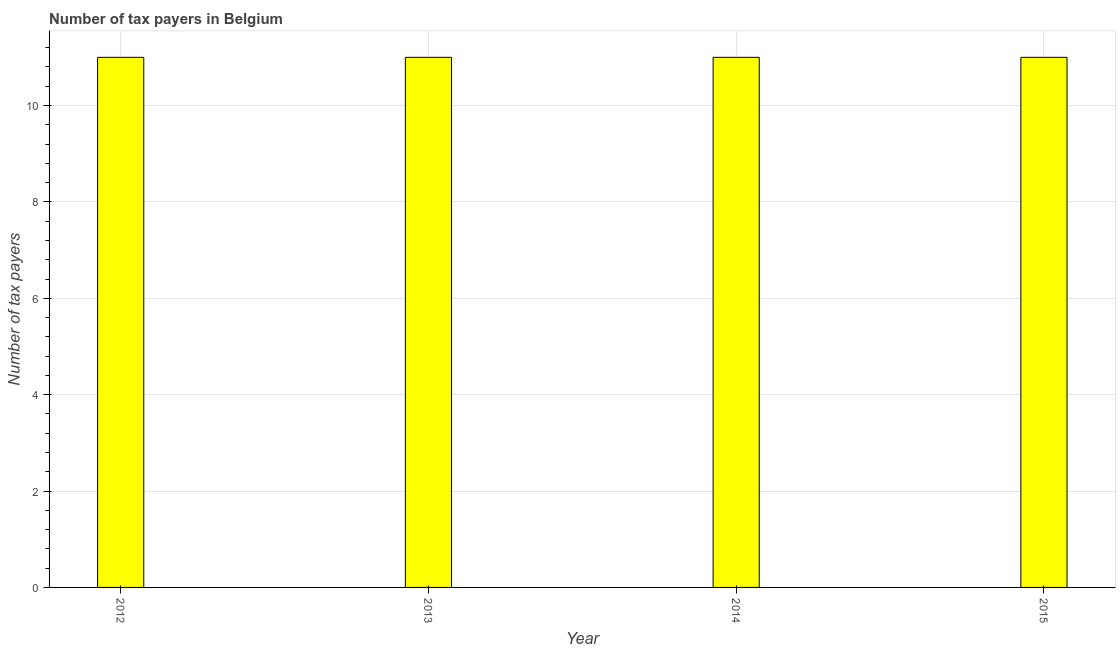Does the graph contain any zero values?
Give a very brief answer. No. Does the graph contain grids?
Your answer should be compact. Yes. What is the title of the graph?
Your answer should be very brief. Number of tax payers in Belgium. What is the label or title of the Y-axis?
Provide a short and direct response. Number of tax payers. What is the number of tax payers in 2012?
Ensure brevity in your answer.  11. Across all years, what is the maximum number of tax payers?
Your answer should be compact. 11. In which year was the number of tax payers minimum?
Your answer should be very brief. 2012. What is the difference between the number of tax payers in 2013 and 2014?
Keep it short and to the point. 0. What is the average number of tax payers per year?
Keep it short and to the point. 11. In how many years, is the number of tax payers greater than 10.4 ?
Your response must be concise. 4. What is the ratio of the number of tax payers in 2013 to that in 2015?
Ensure brevity in your answer.  1. Is the difference between the number of tax payers in 2012 and 2014 greater than the difference between any two years?
Your answer should be compact. Yes. Is the sum of the number of tax payers in 2012 and 2013 greater than the maximum number of tax payers across all years?
Provide a short and direct response. Yes. What is the difference between the highest and the lowest number of tax payers?
Your answer should be compact. 0. In how many years, is the number of tax payers greater than the average number of tax payers taken over all years?
Offer a terse response. 0. How many years are there in the graph?
Make the answer very short. 4. Are the values on the major ticks of Y-axis written in scientific E-notation?
Your response must be concise. No. What is the Number of tax payers of 2014?
Ensure brevity in your answer.  11. What is the Number of tax payers in 2015?
Provide a short and direct response. 11. What is the difference between the Number of tax payers in 2012 and 2013?
Ensure brevity in your answer.  0. What is the difference between the Number of tax payers in 2012 and 2014?
Offer a terse response. 0. What is the ratio of the Number of tax payers in 2012 to that in 2013?
Offer a terse response. 1. What is the ratio of the Number of tax payers in 2013 to that in 2014?
Give a very brief answer. 1. What is the ratio of the Number of tax payers in 2013 to that in 2015?
Keep it short and to the point. 1. 